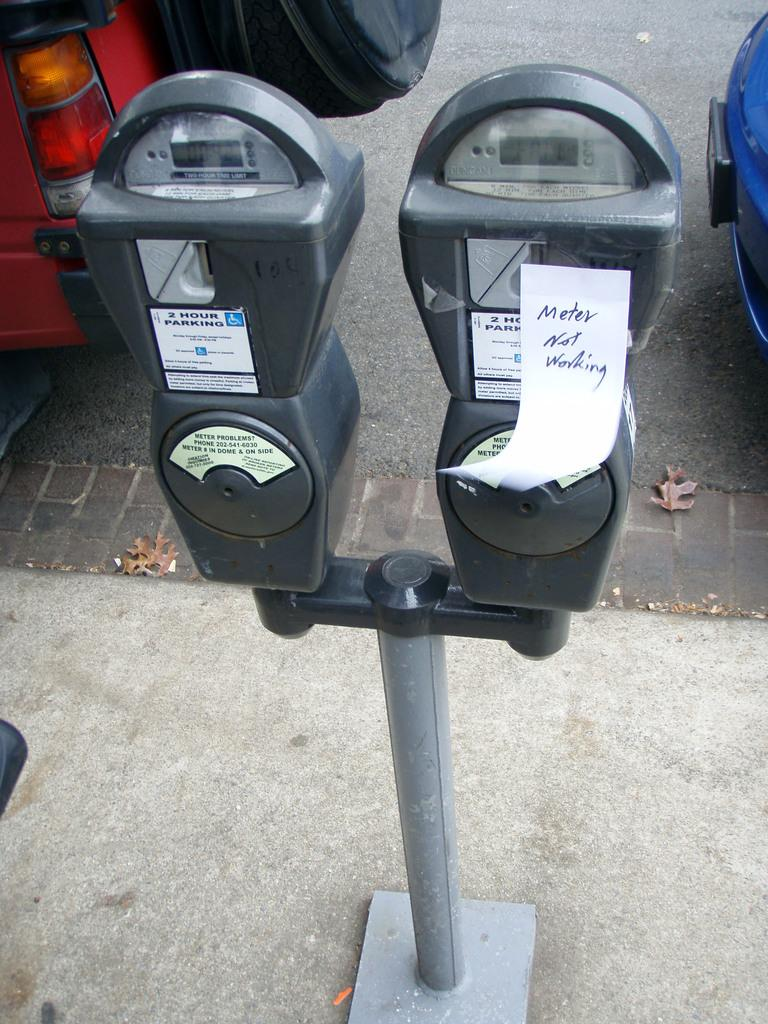<image>
Present a compact description of the photo's key features. A handwritten sign has been posted to the parking meter saying the meter is not working. 